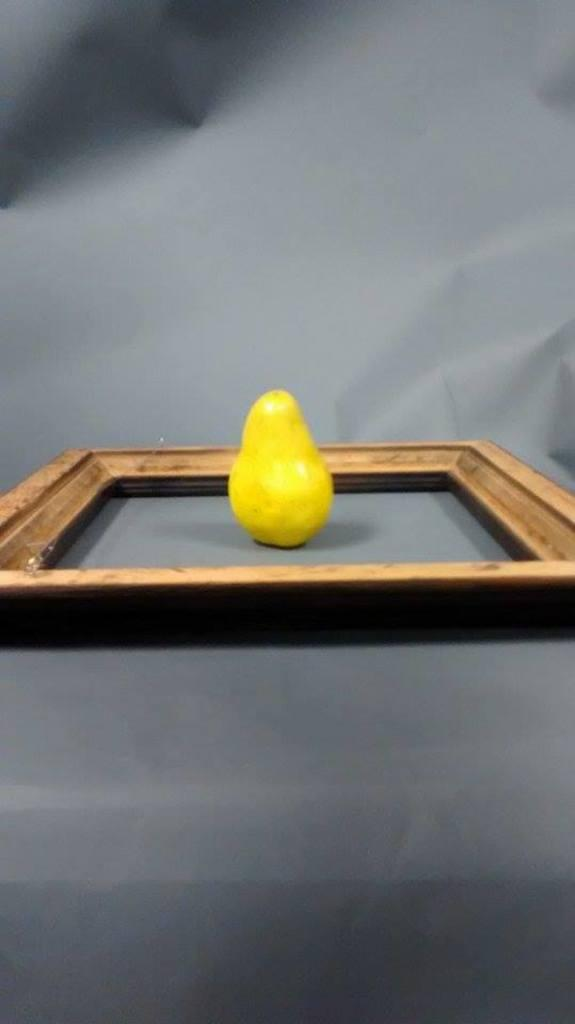What is located in the center of the image? There are objects in the center of the image. Can you describe the background of the image? The background of the image is in an ash color. What type of chain is being taught in the image? There is no chain or teaching activity present in the image. What is the source of the surprise in the image? There is no surprise or indication of surprise in the image. 